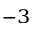<formula> <loc_0><loc_0><loc_500><loc_500>^ { - 3 }</formula> 